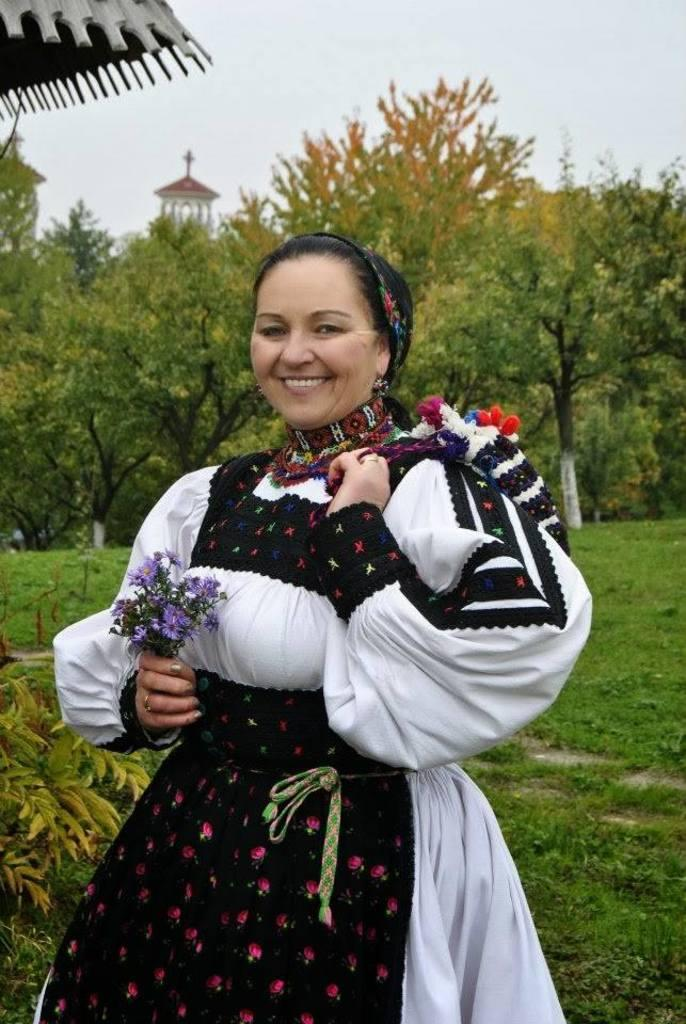What is the main subject of the image? There is a woman standing in the image. What type of terrain is visible in the image? There is grass on the ground in the image. What other natural elements can be seen in the image? There are trees visible in the image. What is visible at the top of the image? The sky is visible at the top of the image. What type of toy can be seen in the woman's hand in the image? There is no toy visible in the woman's hand in the image. What part of the woman's brain can be seen in the image? The image does not show any part of the woman's brain; it only shows her standing. 